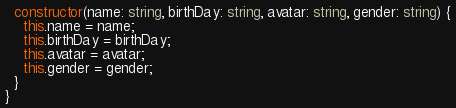Convert code to text. <code><loc_0><loc_0><loc_500><loc_500><_TypeScript_>

  constructor(name: string, birthDay: string, avatar: string, gender: string) {
    this.name = name;
    this.birthDay = birthDay;
    this.avatar = avatar;
    this.gender = gender;
  }
}
</code> 